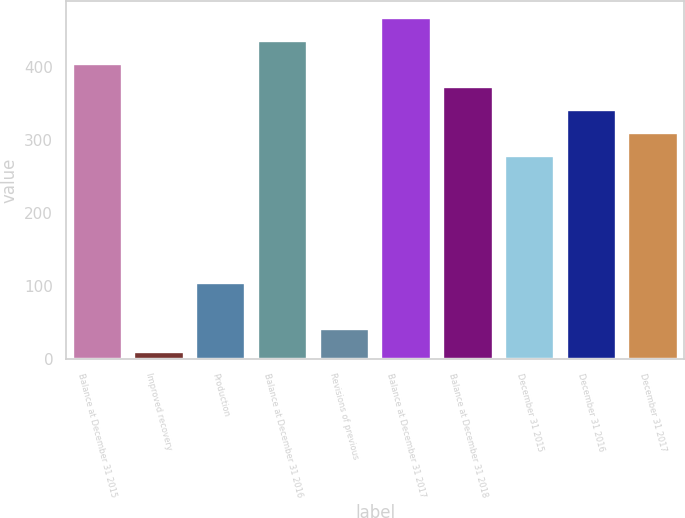<chart> <loc_0><loc_0><loc_500><loc_500><bar_chart><fcel>Balance at December 31 2015<fcel>Improved recovery<fcel>Production<fcel>Balance at December 31 2016<fcel>Revisions of previous<fcel>Balance at December 31 2017<fcel>Balance at December 31 2018<fcel>December 31 2015<fcel>December 31 2016<fcel>December 31 2017<nl><fcel>404.8<fcel>9<fcel>104.1<fcel>436.5<fcel>40.7<fcel>468.2<fcel>373.1<fcel>278<fcel>341.4<fcel>309.7<nl></chart> 